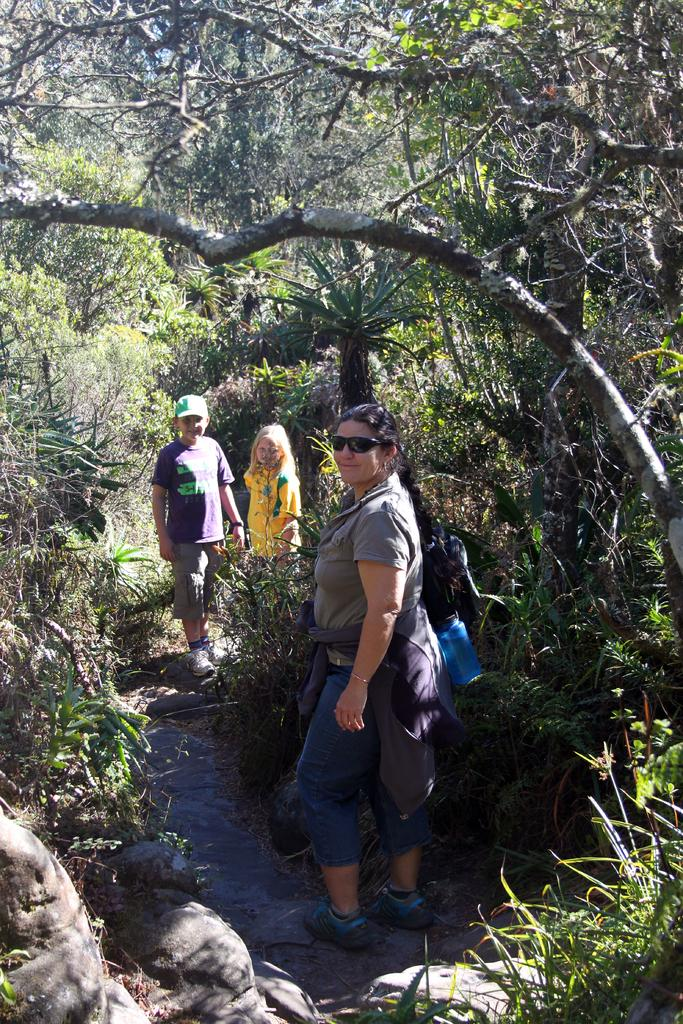What is the primary setting of the image? The primary setting of the image is the ground, where persons are standing. What type of natural features can be seen in the image? There are rocks and trees visible in the image. What can be seen in the background of the image? There are trees visible in the background of the image. What flavor of ice cream is being served in the room in the image? There is no room or ice cream present in the image; it features persons standing on the ground with rocks and trees. 